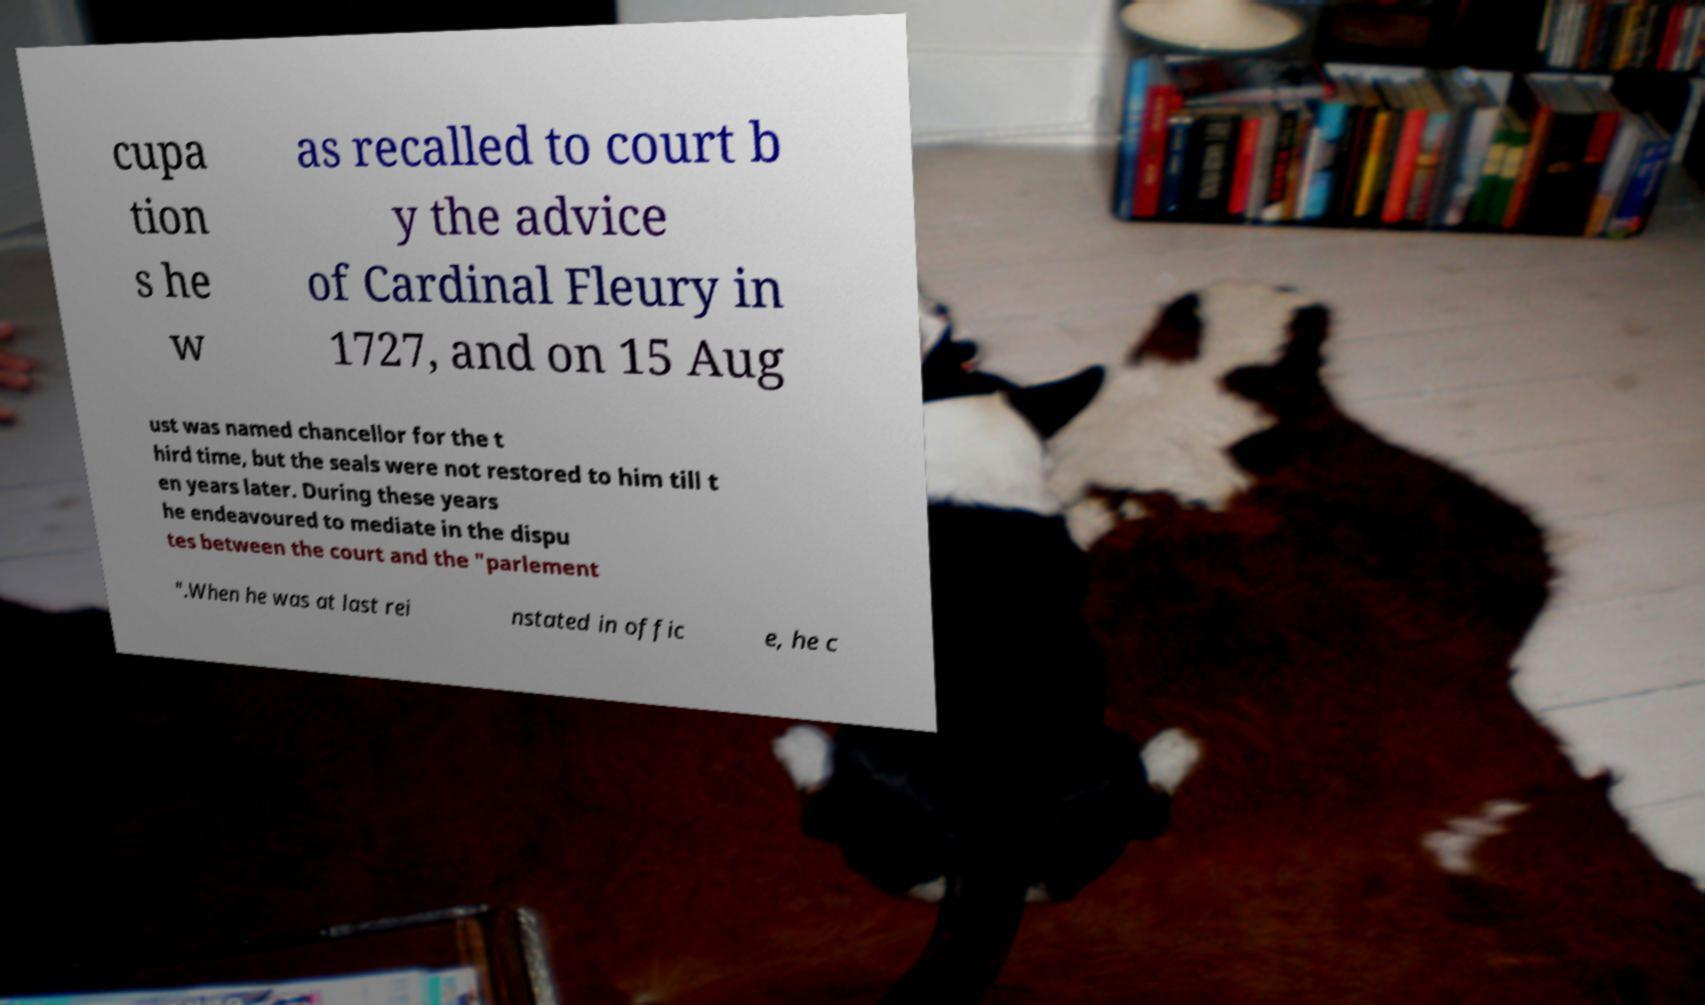Can you read and provide the text displayed in the image?This photo seems to have some interesting text. Can you extract and type it out for me? cupa tion s he w as recalled to court b y the advice of Cardinal Fleury in 1727, and on 15 Aug ust was named chancellor for the t hird time, but the seals were not restored to him till t en years later. During these years he endeavoured to mediate in the dispu tes between the court and the "parlement ".When he was at last rei nstated in offic e, he c 